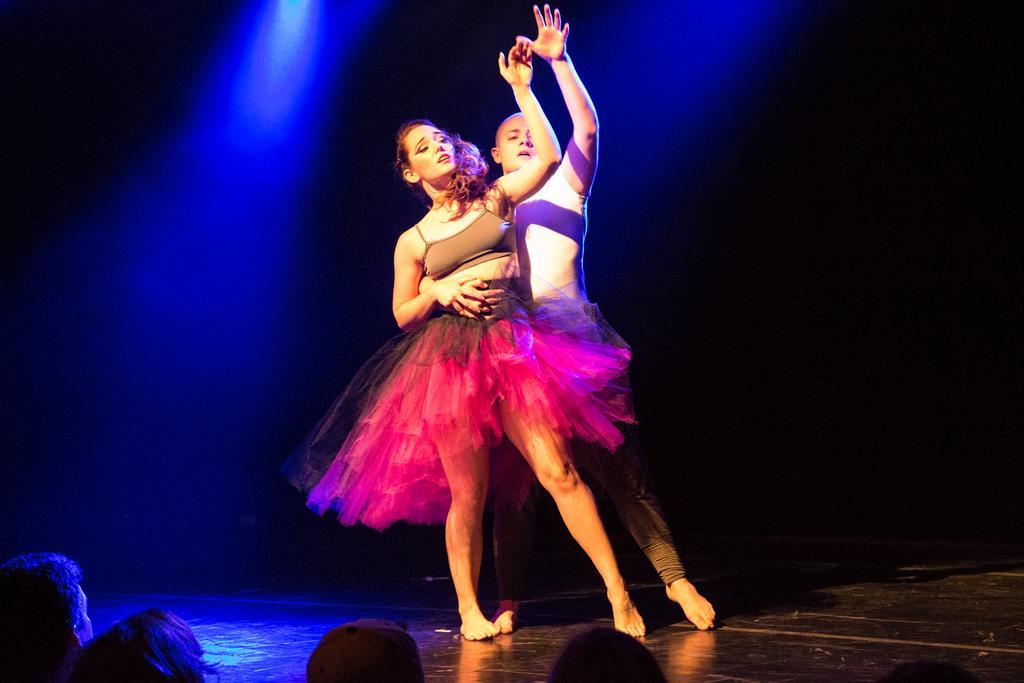How would you summarize this image in a sentence or two? This picture shows a man and women dancing on the floor and we see a man holding a woman with his hand and we see few people watching them. 